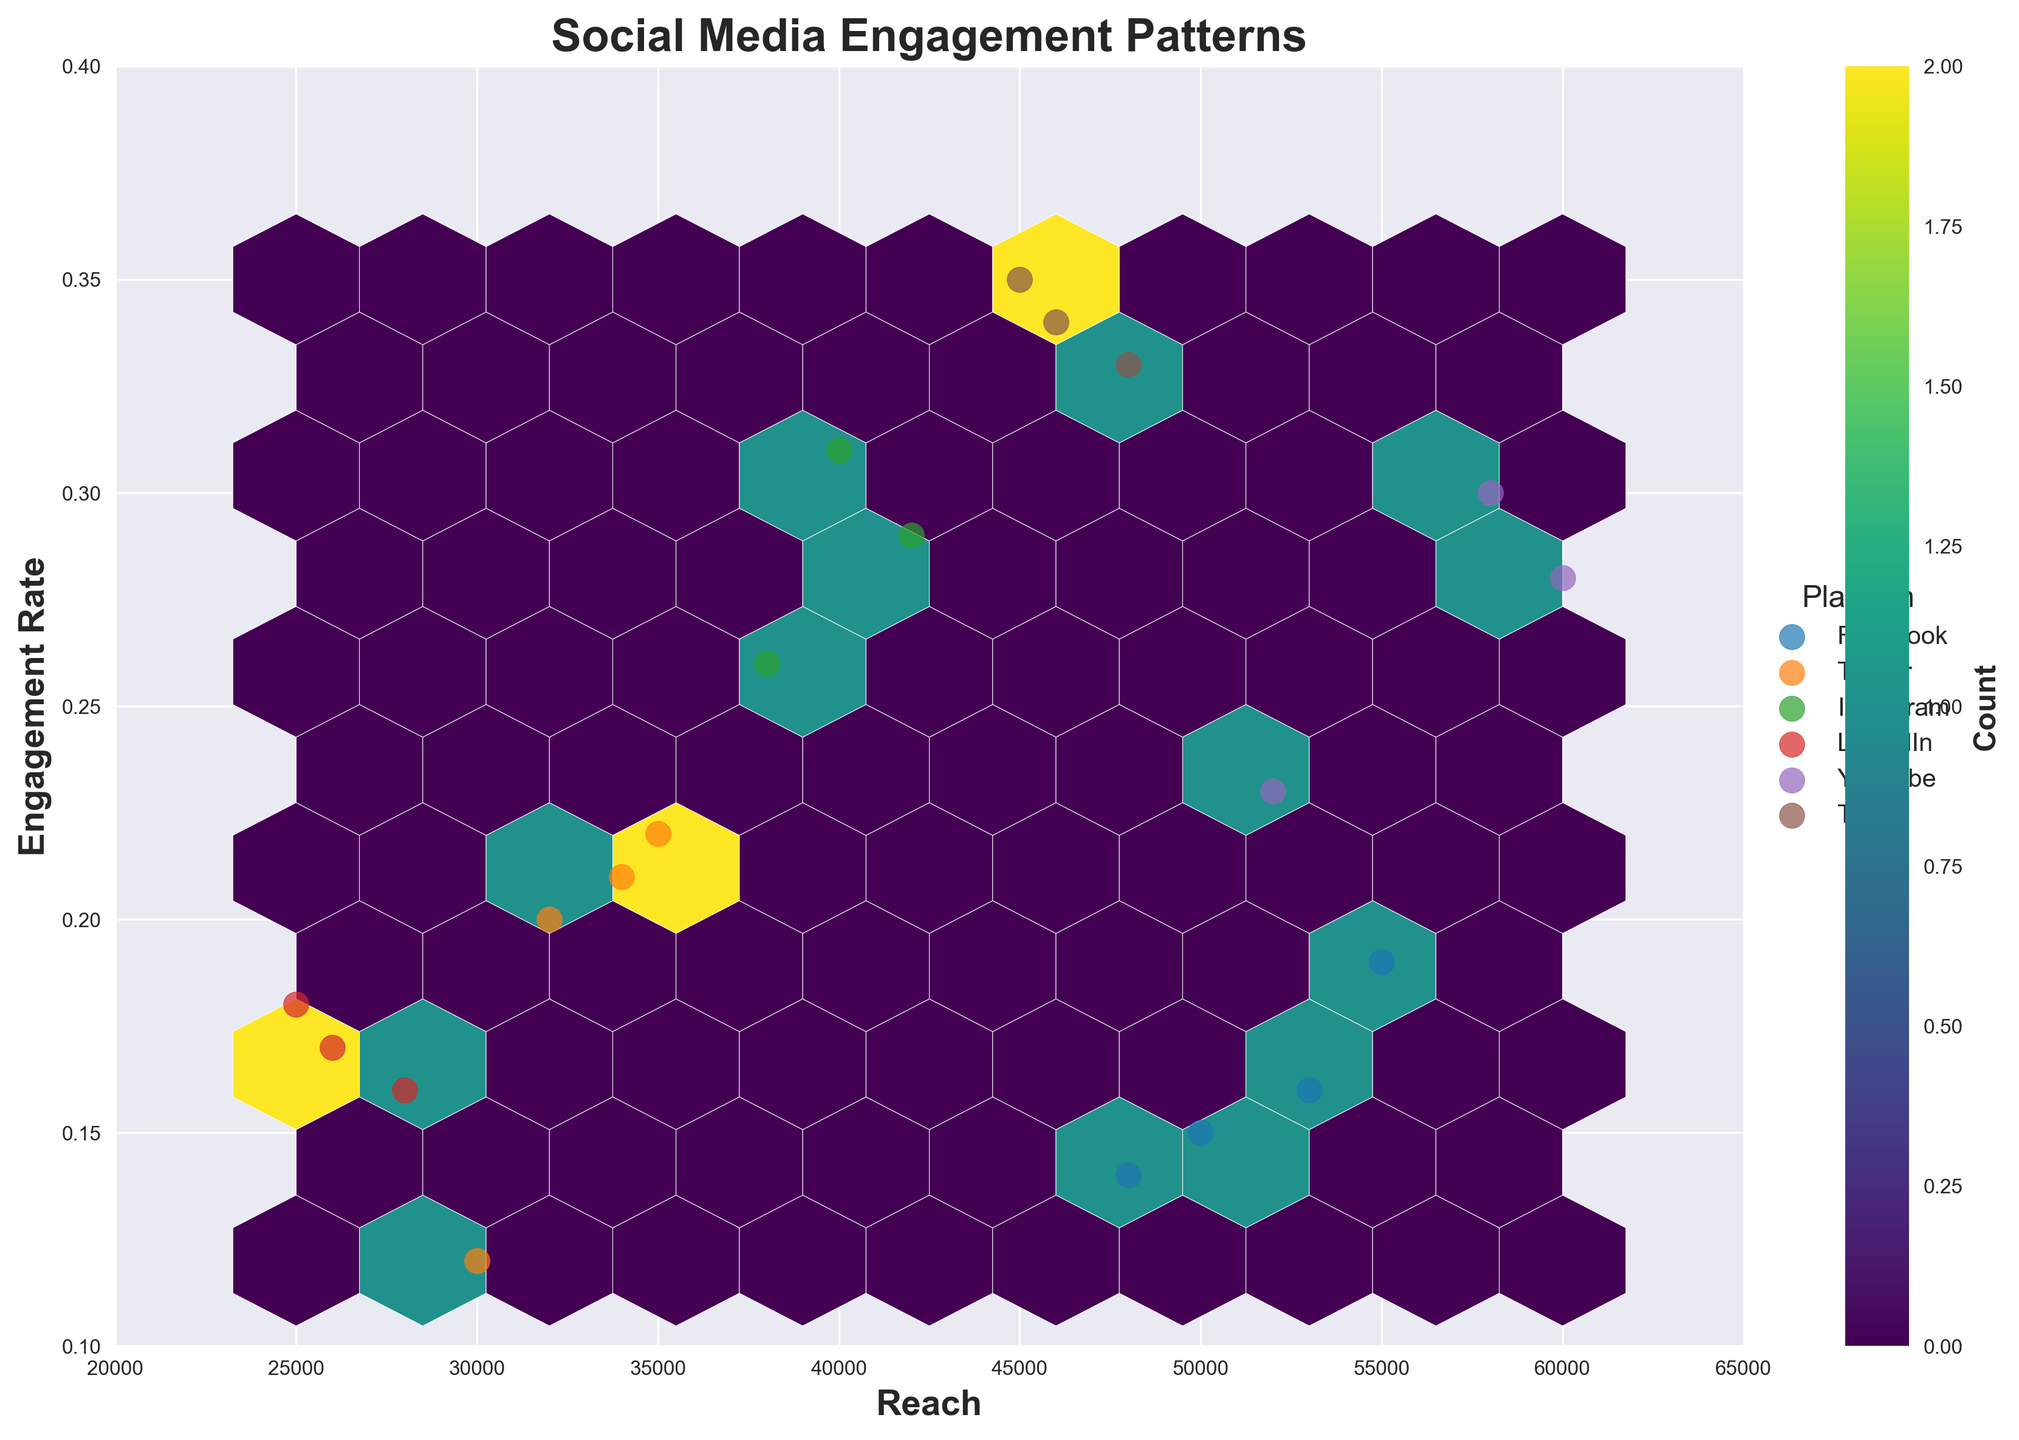What is the title of the Hexbin Plot? The title of the plot is displayed prominently at the top, typically in a larger and bold font. It summarizes the content of the plot. Here, it reads "Social Media Engagement Patterns".
Answer: Social Media Engagement Patterns What are the labels of the x and y axes? The x-axis and y-axis labels are displayed along the respective axes, usually in a bold font. The x-axis label is 'Reach', and the y-axis label is 'Engagement Rate'.
Answer: Reach and Engagement Rate How many data points (hexbins) are denser in terms of count in the plot? To determine the denser hexbins, one must refer to the color gradient in the plot. The color bar indicates the count, with darker shades representing higher counts. By counting these darker hexbins, we infer that there are about 4 hexbins with a higher density.
Answer: About 4 Which platform typically has the highest engagement rates? By looking at the scatter points representing different platforms, TikTok's points are consistently towards the upper end of the engagement rate spectrum, indicating it typically has the highest engagement rates.
Answer: TikTok What platform has the widest variation in reach? Observing the scatter points for each platform spread along the x-axis (reach), YouTube shows the widest variation in reach, with points ranging from lower to higher values on the x-axis.
Answer: YouTube Which type of content tends to have the highest reach? By cross-referencing the scatter points and the legend, YouTube's 'Live Performances' represent the highest reach, as indicated by its position furthest to the right on the x-axis.
Answer: Live Performances Is there a positive correlation between reach and engagement rate? The spread of the hexbins and scatter points from lower left to upper right suggests that as reach increases, engagement rate also tends to increase, indicating a positive correlation.
Answer: Yes How does Facebook's engagement rate distribution compare with TikTok's? Facebook's scatter points show a more modest spread and position on the lower engagement rate spectrum compared to TikTok's points, which are higher up on the y-axis. This indicates the engagement rate for Facebook is generally lower than for TikTok.
Answer: Facebook generally lower What is the color bar label, and what does it represent? The color bar label is shown adjacent to the color bar itself and indicates the metric it measures. Here, it reads 'Count', representing the number of data points (hexagons) in each color gradient.
Answer: Count 